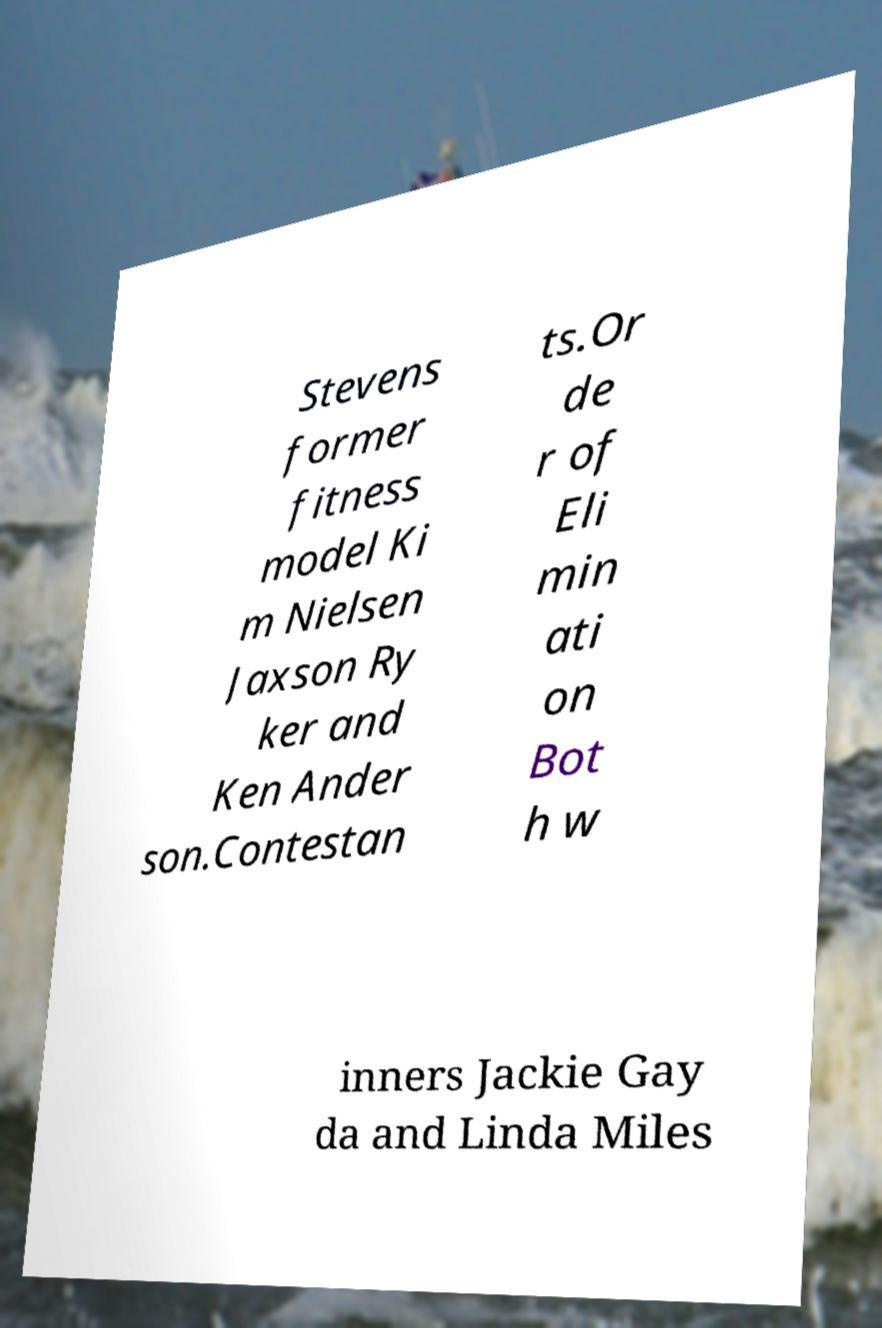There's text embedded in this image that I need extracted. Can you transcribe it verbatim? Stevens former fitness model Ki m Nielsen Jaxson Ry ker and Ken Ander son.Contestan ts.Or de r of Eli min ati on Bot h w inners Jackie Gay da and Linda Miles 